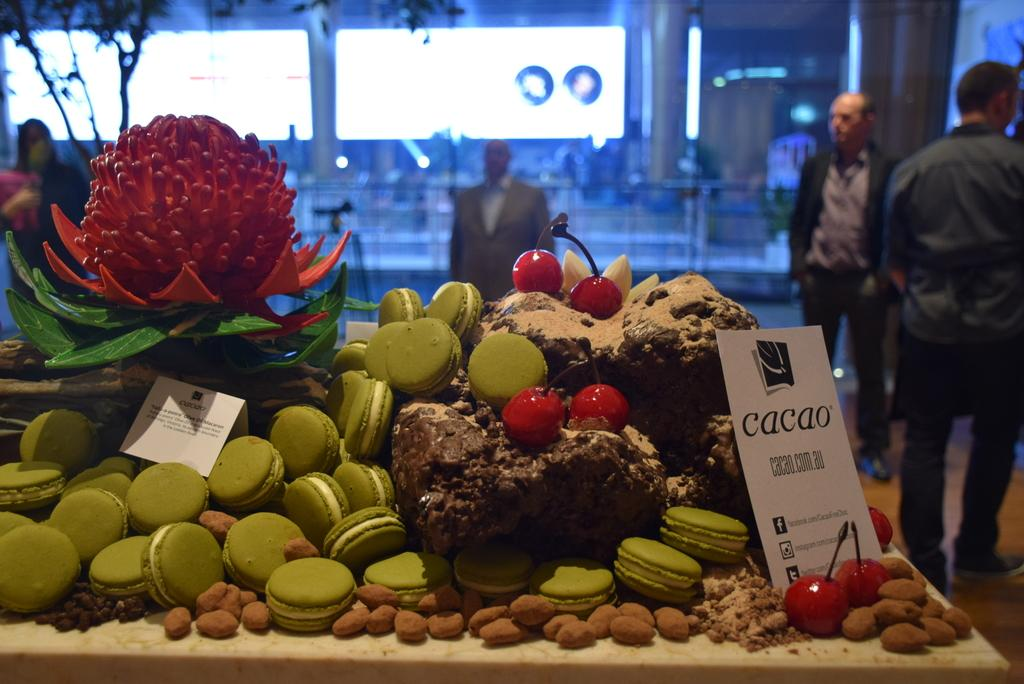How many people are in the image? There are people in the image, but the exact number is not specified. What is the primary object in the image? There is a screen in the image. What type of surface is present in the image? There is a wall and a table in the image. What food items can be seen on the table? There are nuts, cherries, biscuits, and a fruit on the table. What type of skin is visible on the servant in the image? There is no servant present in the image, and therefore no skin to describe. What year is depicted in the image? The year is not mentioned in the image or the provided facts, so it cannot be determined. 